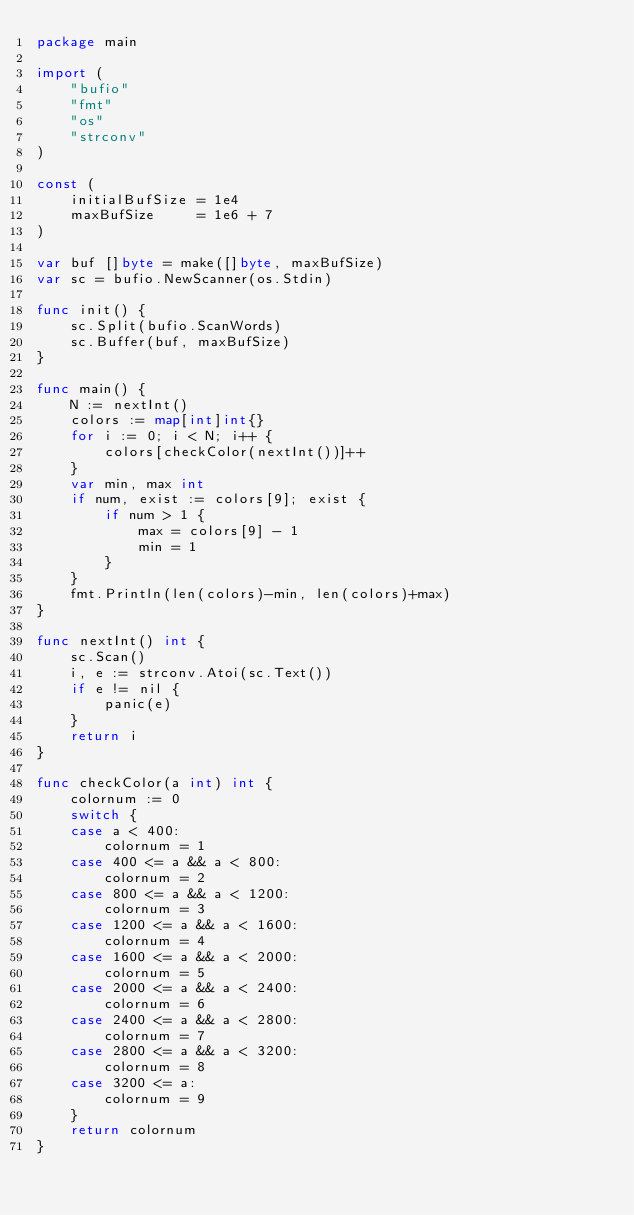<code> <loc_0><loc_0><loc_500><loc_500><_Go_>package main

import (
	"bufio"
	"fmt"
	"os"
	"strconv"
)

const (
	initialBufSize = 1e4
	maxBufSize     = 1e6 + 7
)

var buf []byte = make([]byte, maxBufSize)
var sc = bufio.NewScanner(os.Stdin)

func init() {
	sc.Split(bufio.ScanWords)
	sc.Buffer(buf, maxBufSize)
}

func main() {
	N := nextInt()
	colors := map[int]int{}
	for i := 0; i < N; i++ {
		colors[checkColor(nextInt())]++
	}
	var min, max int
	if num, exist := colors[9]; exist {
		if num > 1 {
			max = colors[9] - 1
			min = 1
		}
	}
	fmt.Println(len(colors)-min, len(colors)+max)
}

func nextInt() int {
	sc.Scan()
	i, e := strconv.Atoi(sc.Text())
	if e != nil {
		panic(e)
	}
	return i
}

func checkColor(a int) int {
	colornum := 0
	switch {
	case a < 400:
		colornum = 1
	case 400 <= a && a < 800:
		colornum = 2
	case 800 <= a && a < 1200:
		colornum = 3
	case 1200 <= a && a < 1600:
		colornum = 4
	case 1600 <= a && a < 2000:
		colornum = 5
	case 2000 <= a && a < 2400:
		colornum = 6
	case 2400 <= a && a < 2800:
		colornum = 7
	case 2800 <= a && a < 3200:
		colornum = 8
	case 3200 <= a:
		colornum = 9
	}
	return colornum
}
</code> 